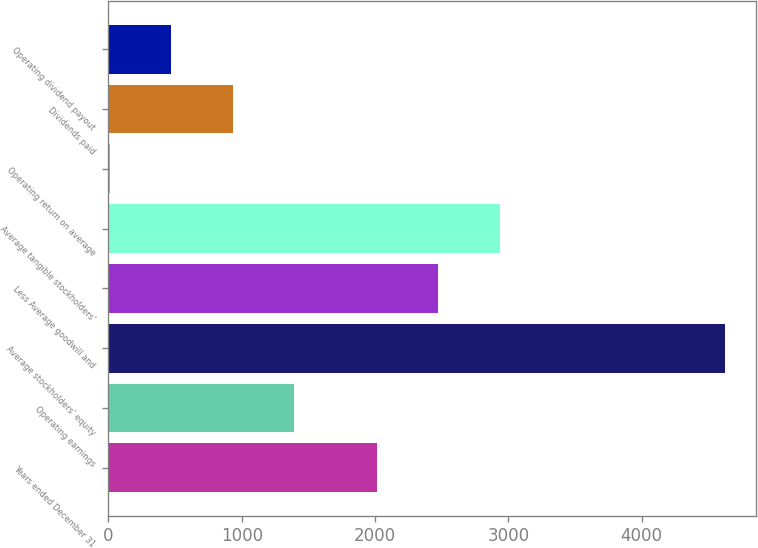Convert chart. <chart><loc_0><loc_0><loc_500><loc_500><bar_chart><fcel>Years ended December 31<fcel>Operating earnings<fcel>Average stockholders' equity<fcel>Less Average goodwill and<fcel>Average tangible stockholders'<fcel>Operating return on average<fcel>Dividends paid<fcel>Operating dividend payout<nl><fcel>2014<fcel>1394.29<fcel>4625<fcel>2475.53<fcel>2937.06<fcel>9.7<fcel>932.76<fcel>471.23<nl></chart> 